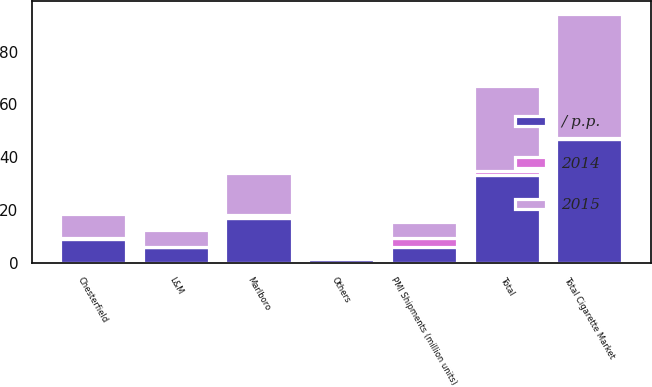Convert chart to OTSL. <chart><loc_0><loc_0><loc_500><loc_500><stacked_bar_chart><ecel><fcel>Total Cigarette Market<fcel>PMI Shipments (million units)<fcel>Marlboro<fcel>Chesterfield<fcel>L&M<fcel>Others<fcel>Total<nl><fcel>/ p.p.<fcel>46.7<fcel>5.8<fcel>17<fcel>9.1<fcel>5.8<fcel>1.5<fcel>33.4<nl><fcel>2015<fcel>47<fcel>5.8<fcel>15.9<fcel>9.2<fcel>6.1<fcel>0.9<fcel>32.1<nl><fcel>2014<fcel>0.6<fcel>3.7<fcel>1.1<fcel>0.1<fcel>0.3<fcel>0.6<fcel>1.3<nl></chart> 